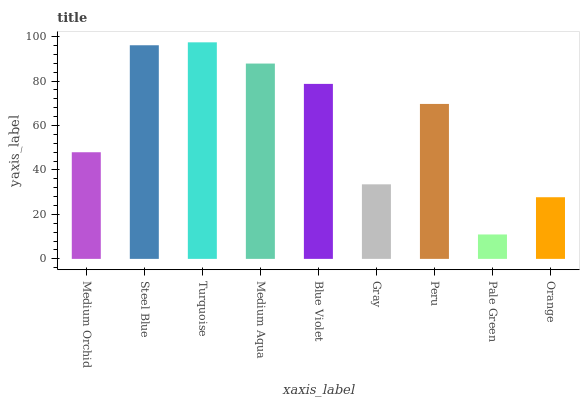Is Turquoise the maximum?
Answer yes or no. Yes. Is Steel Blue the minimum?
Answer yes or no. No. Is Steel Blue the maximum?
Answer yes or no. No. Is Steel Blue greater than Medium Orchid?
Answer yes or no. Yes. Is Medium Orchid less than Steel Blue?
Answer yes or no. Yes. Is Medium Orchid greater than Steel Blue?
Answer yes or no. No. Is Steel Blue less than Medium Orchid?
Answer yes or no. No. Is Peru the high median?
Answer yes or no. Yes. Is Peru the low median?
Answer yes or no. Yes. Is Pale Green the high median?
Answer yes or no. No. Is Medium Aqua the low median?
Answer yes or no. No. 